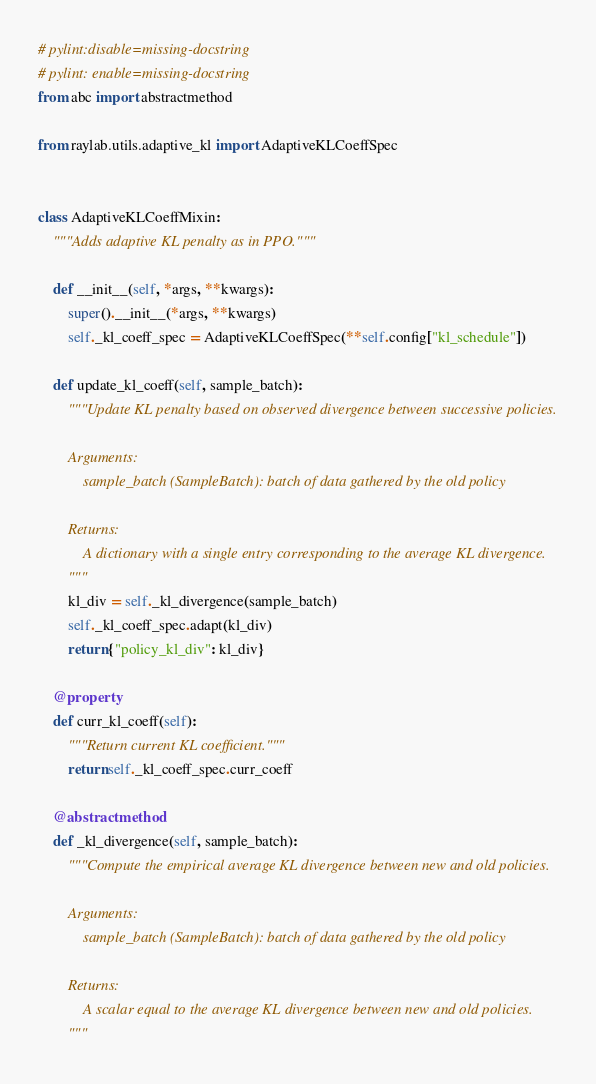Convert code to text. <code><loc_0><loc_0><loc_500><loc_500><_Python_># pylint:disable=missing-docstring
# pylint: enable=missing-docstring
from abc import abstractmethod

from raylab.utils.adaptive_kl import AdaptiveKLCoeffSpec


class AdaptiveKLCoeffMixin:
    """Adds adaptive KL penalty as in PPO."""

    def __init__(self, *args, **kwargs):
        super().__init__(*args, **kwargs)
        self._kl_coeff_spec = AdaptiveKLCoeffSpec(**self.config["kl_schedule"])

    def update_kl_coeff(self, sample_batch):
        """Update KL penalty based on observed divergence between successive policies.

        Arguments:
            sample_batch (SampleBatch): batch of data gathered by the old policy

        Returns:
            A dictionary with a single entry corresponding to the average KL divergence.
        """
        kl_div = self._kl_divergence(sample_batch)
        self._kl_coeff_spec.adapt(kl_div)
        return {"policy_kl_div": kl_div}

    @property
    def curr_kl_coeff(self):
        """Return current KL coefficient."""
        return self._kl_coeff_spec.curr_coeff

    @abstractmethod
    def _kl_divergence(self, sample_batch):
        """Compute the empirical average KL divergence between new and old policies.

        Arguments:
            sample_batch (SampleBatch): batch of data gathered by the old policy

        Returns:
            A scalar equal to the average KL divergence between new and old policies.
        """
</code> 